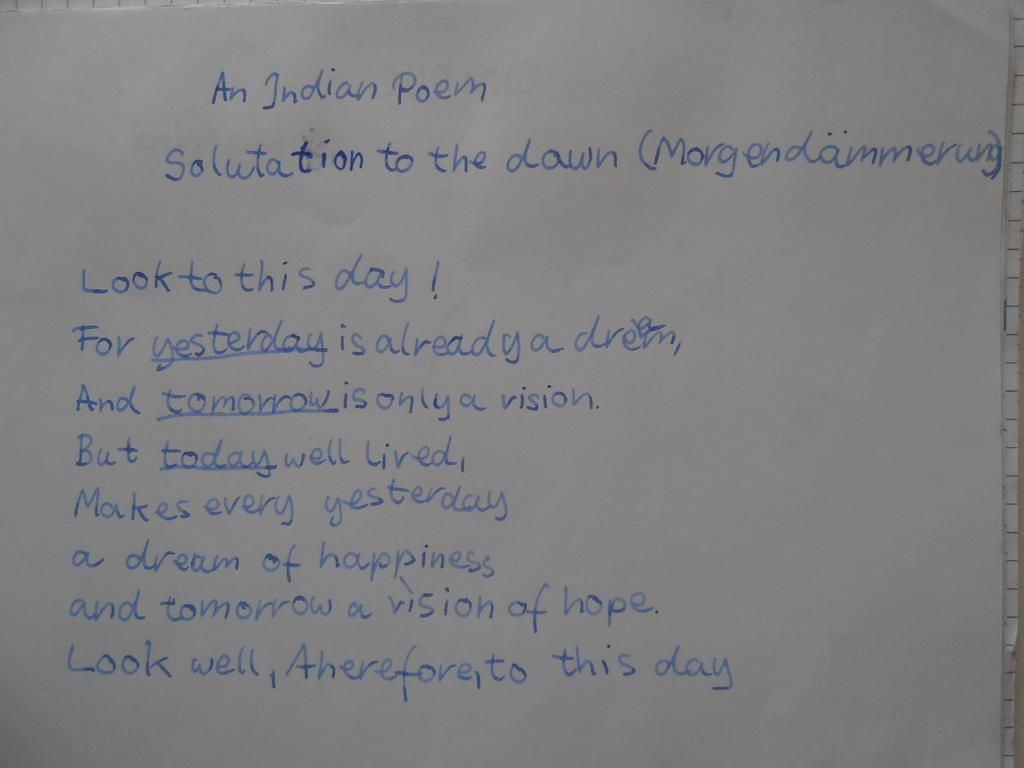<image>
Create a compact narrative representing the image presented. An Indian poem titled Salutation to the Dawn is written in blue colored pencil. 